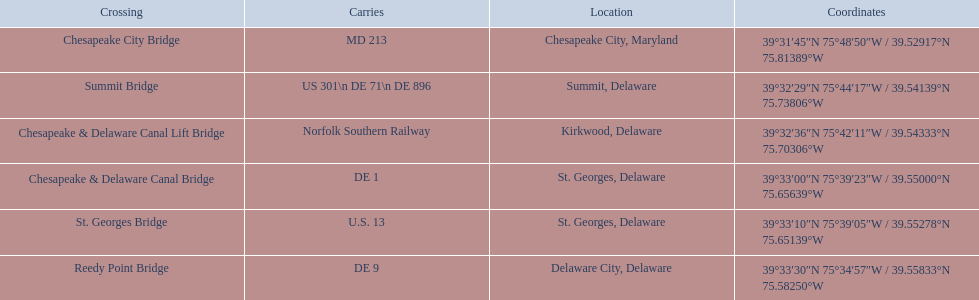What are the bridges? Chesapeake City Bridge, Summit Bridge, Chesapeake & Delaware Canal Lift Bridge, Chesapeake & Delaware Canal Bridge, St. Georges Bridge, Reedy Point Bridge. Which ones are in delaware? Summit Bridge, Chesapeake & Delaware Canal Lift Bridge, Chesapeake & Delaware Canal Bridge, St. Georges Bridge, Reedy Point Bridge. Among them, which supports de 9? Reedy Point Bridge. What are the titles of the significant intersections for the chesapeake and delaware canal? Chesapeake City Bridge, Summit Bridge, Chesapeake & Delaware Canal Lift Bridge, Chesapeake & Delaware Canal Bridge, St. Georges Bridge, Reedy Point Bridge. What paths are supported by these intersections? MD 213, US 301\n DE 71\n DE 896, Norfolk Southern Railway, DE 1, U.S. 13, DE 9. Parse the full table in json format. {'header': ['Crossing', 'Carries', 'Location', 'Coordinates'], 'rows': [['Chesapeake City Bridge', 'MD 213', 'Chesapeake City, Maryland', '39°31′45″N 75°48′50″W\ufeff / \ufeff39.52917°N 75.81389°W'], ['Summit Bridge', 'US 301\\n DE 71\\n DE 896', 'Summit, Delaware', '39°32′29″N 75°44′17″W\ufeff / \ufeff39.54139°N 75.73806°W'], ['Chesapeake & Delaware Canal Lift Bridge', 'Norfolk Southern Railway', 'Kirkwood, Delaware', '39°32′36″N 75°42′11″W\ufeff / \ufeff39.54333°N 75.70306°W'], ['Chesapeake & Delaware Canal Bridge', 'DE 1', 'St.\xa0Georges, Delaware', '39°33′00″N 75°39′23″W\ufeff / \ufeff39.55000°N 75.65639°W'], ['St.\xa0Georges Bridge', 'U.S.\xa013', 'St.\xa0Georges, Delaware', '39°33′10″N 75°39′05″W\ufeff / \ufeff39.55278°N 75.65139°W'], ['Reedy Point Bridge', 'DE\xa09', 'Delaware City, Delaware', '39°33′30″N 75°34′57″W\ufeff / \ufeff39.55833°N 75.58250°W']]} Which of those paths consists of multiple paths? US 301\n DE 71\n DE 896. Which intersection holds those paths? Summit Bridge. 